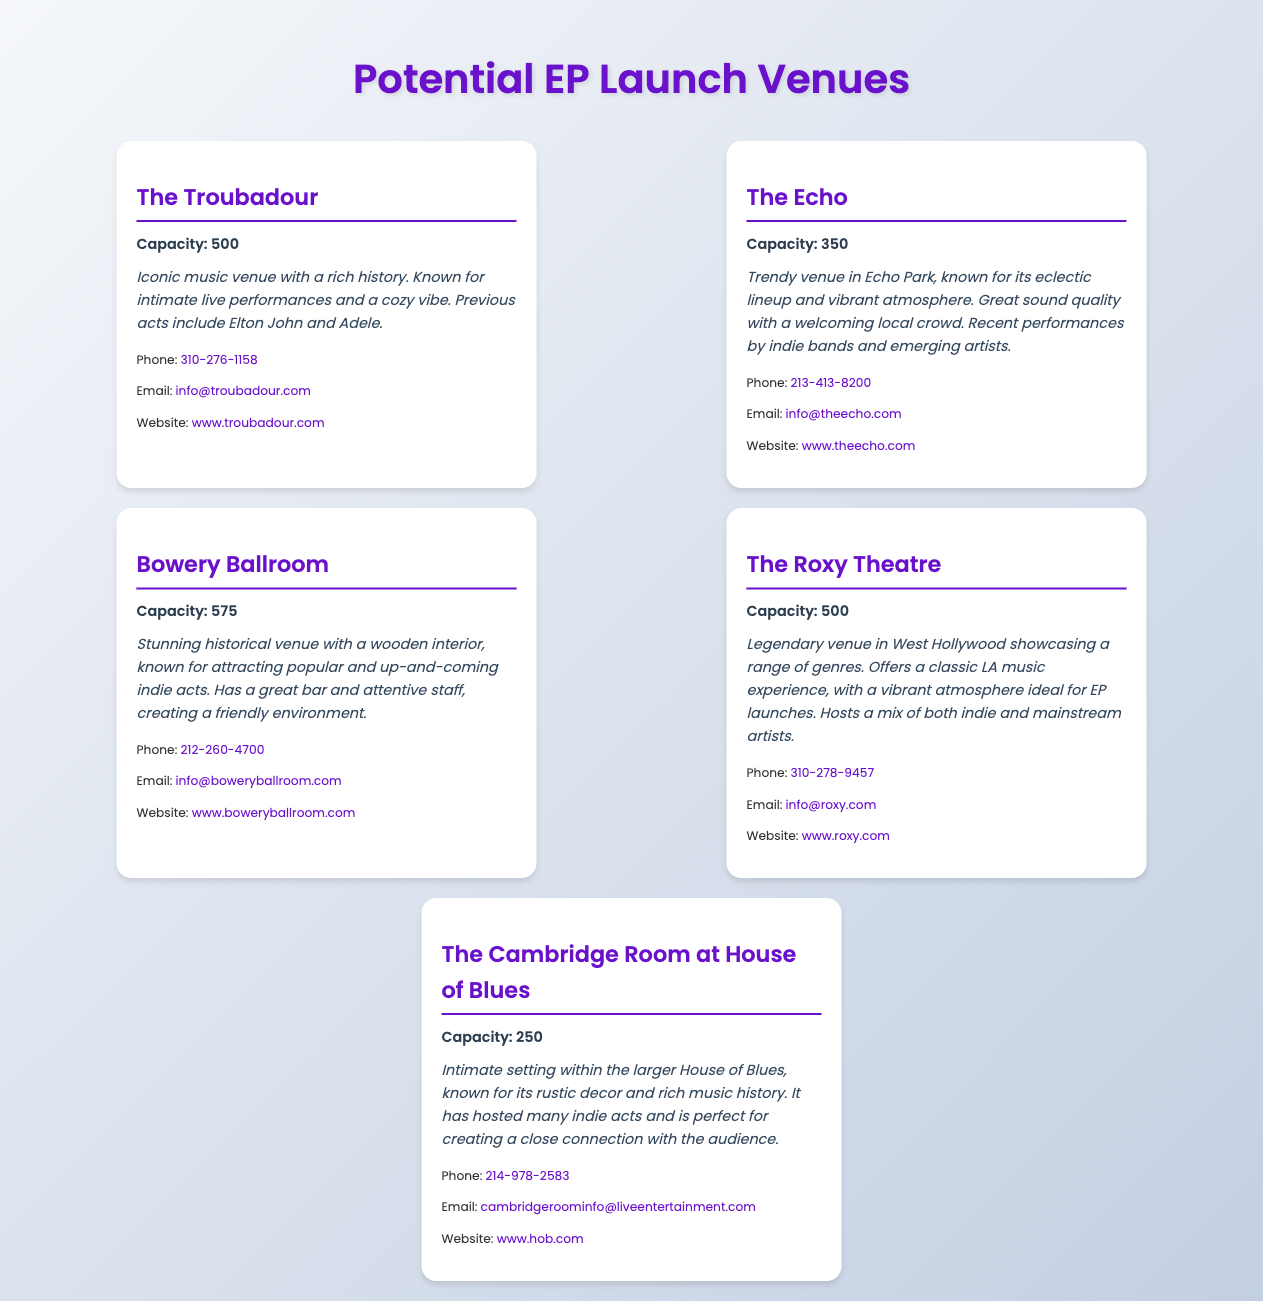What is the capacity of The Troubadour? The capacity is specified in the venue card for The Troubadour, which is 500.
Answer: 500 What is the email address for The Echo? The document provides contact information, including the email address for The Echo as info@theecho.com.
Answer: info@theecho.com Name one previous act at Bowery Ballroom. The document lists notable previous acts at Bowery Ballroom, including popular artists like Adele and Elton John.
Answer: Elton John Which venue has a capacity of 250? The Cambridge Room at House of Blues has its specific capacity mentioned in its card, which is 250.
Answer: 250 What is the atmosphere description for The Roxy Theatre? The document includes an atmosphere description that highlights The Roxy Theatre’s classic LA music experience and vibrant atmosphere.
Answer: Classic LA music experience How many venues listed has a capacity over 500? By reviewing the capacity listings, one can determine that there is only one venue, Bowery Ballroom, with a capacity above 500.
Answer: 1 What kind of performances does The Echo host? The Echo is known for its eclectic lineup and features performances from indie bands and emerging artists.
Answer: Indie bands and emerging artists Which venue is described as having rustic decor? The Cambridge Room at House of Blues is noted for its rustic decor in the atmosphere description.
Answer: The Cambridge Room at House of Blues What is the website for The Roxy Theatre? The contact information includes the website for The Roxy Theatre as www.roxy.com.
Answer: www.roxy.com 